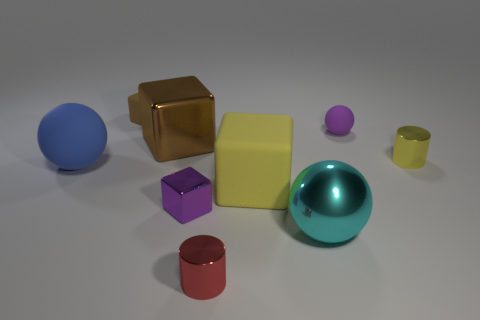Add 1 big cyan metallic things. How many objects exist? 10 Subtract all cylinders. How many objects are left? 7 Subtract 1 purple balls. How many objects are left? 8 Subtract all brown things. Subtract all large red blocks. How many objects are left? 7 Add 9 brown matte objects. How many brown matte objects are left? 10 Add 7 metal cubes. How many metal cubes exist? 9 